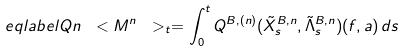Convert formula to latex. <formula><loc_0><loc_0><loc_500><loc_500>\ e q l a b e l { Q n } \ < M ^ { n } \ > _ { t } = \int ^ { t } _ { 0 } Q ^ { B , ( n ) } ( \tilde { X } ^ { B , n } _ { s } , \tilde { \Lambda } ^ { B , n } _ { s } ) ( f , a ) \, d s</formula> 